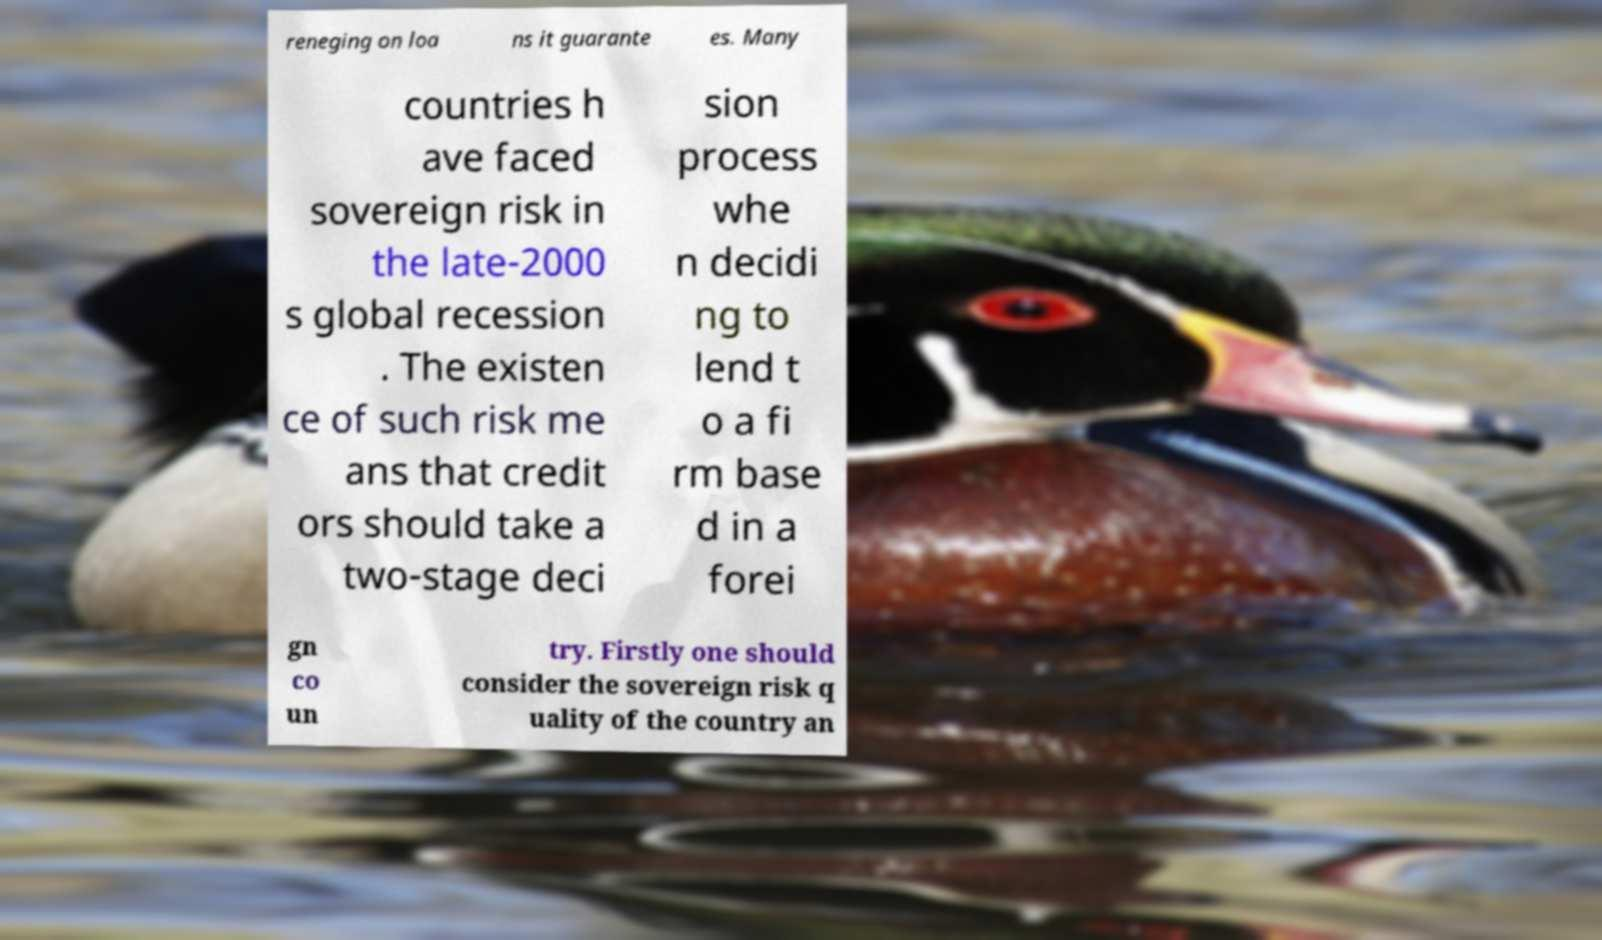Please identify and transcribe the text found in this image. reneging on loa ns it guarante es. Many countries h ave faced sovereign risk in the late-2000 s global recession . The existen ce of such risk me ans that credit ors should take a two-stage deci sion process whe n decidi ng to lend t o a fi rm base d in a forei gn co un try. Firstly one should consider the sovereign risk q uality of the country an 